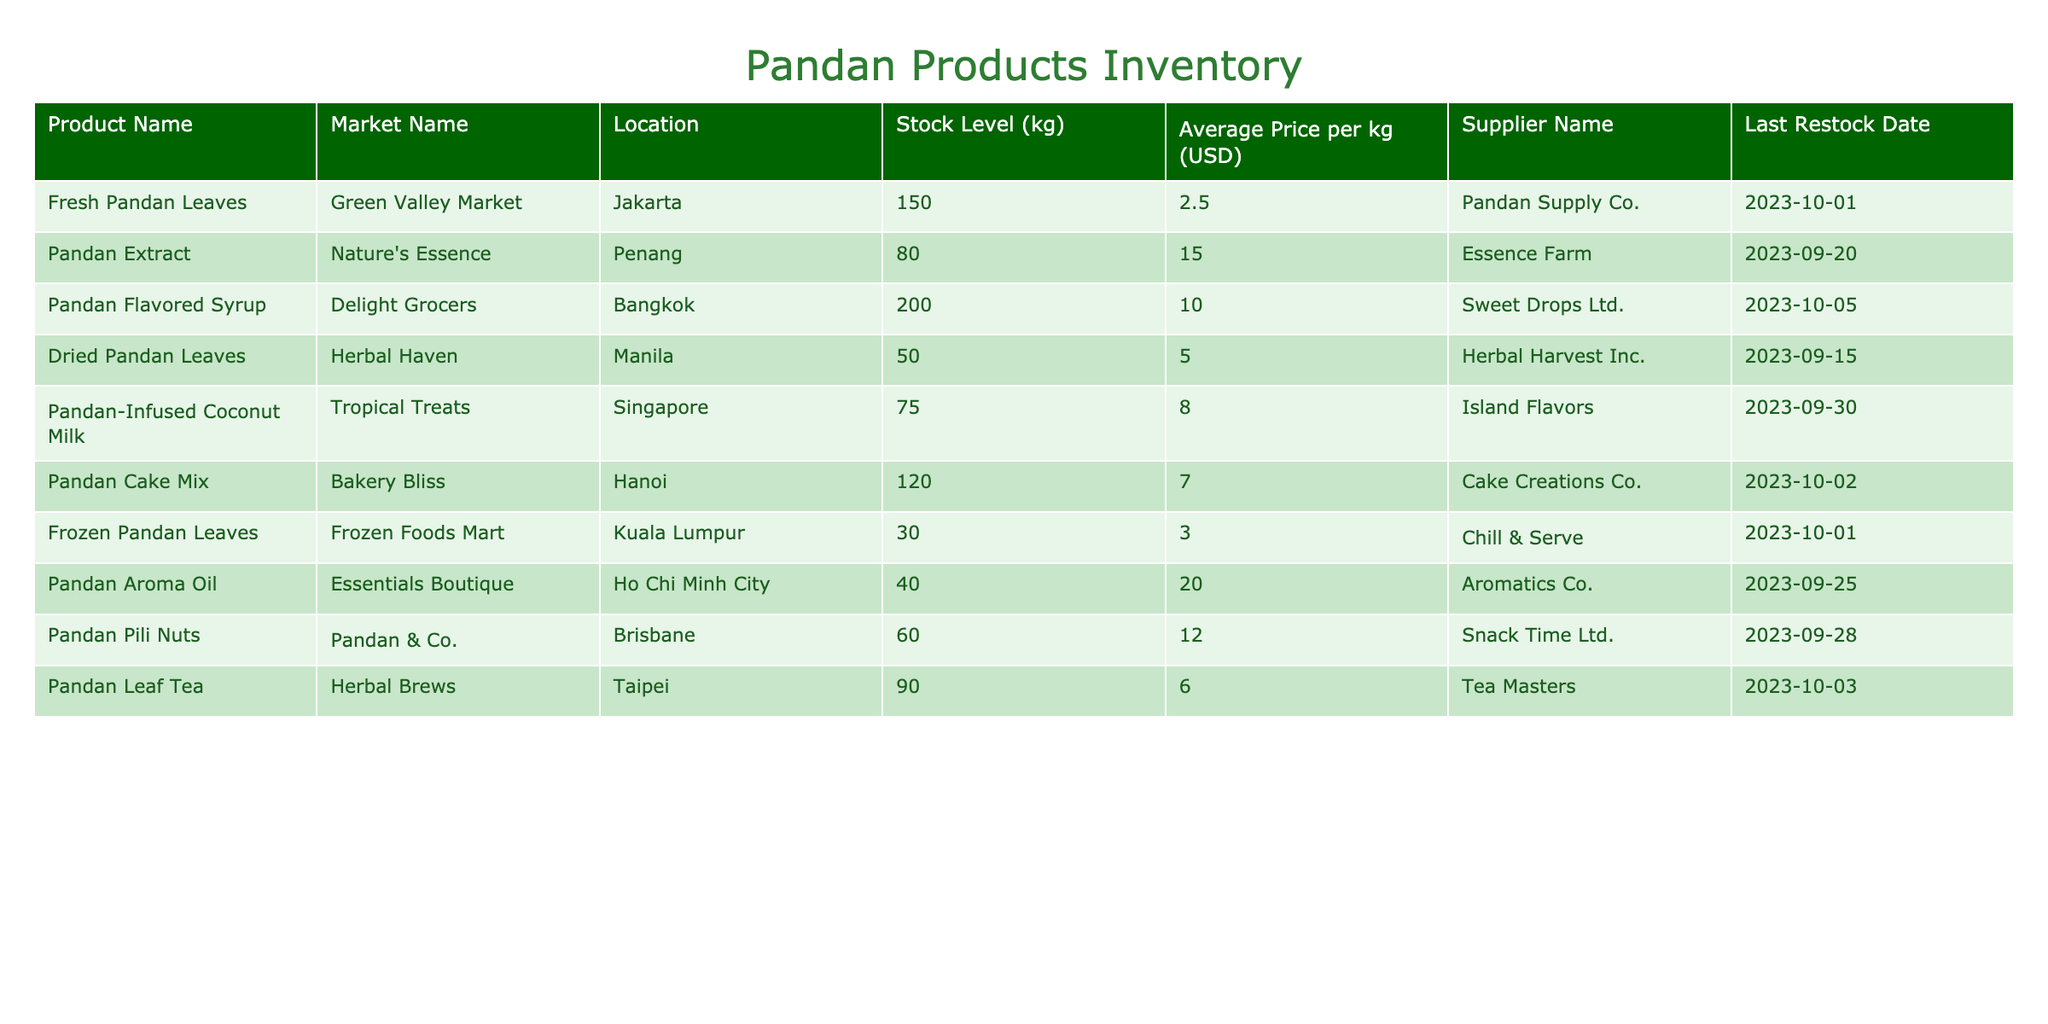What is the stock level of Fresh Pandan Leaves at Green Valley Market? The stock level of Fresh Pandan Leaves is listed under the "Stock Level (kg)" column for Green Valley Market. Looking at the table, it shows a stock level of 150 kg.
Answer: 150 kg Which product has the highest average price per kg? To find out which product has the highest price, we can compare the "Average Price per kg (USD)" values across all products. The Pandan Aroma Oil has the highest price listed at 20.00 USD.
Answer: 20.00 USD What are the stock levels of Pandan products available in Singapore? In Singapore, we have one product, which is Pandan-Infused Coconut Milk. The stock level for this product is 75 kg, as visible in the table.
Answer: 75 kg Is the stock level of Frozen Pandan Leaves greater than 50 kg? The stock level for Frozen Pandan Leaves is listed as 30 kg. Since 30 is less than 50, we can confidently answer no to this question.
Answer: No What is the total stock level of Pandan products from suppliers with names that include "Pandan"? The suppliers with names including "Pandan" are Pandan Supply Co., Pandan & Co. We need to sum their stock levels (150 kg for Fresh Pandan Leaves and 60 kg for Pandan Pili Nuts). Therefore, the total is 150 + 60 = 210 kg.
Answer: 210 kg Are there any products with a stock level less than 40 kg? Looking through the stock levels in the table, there are no products listed with a stock level below 30 kg for Frozen Pandan Leaves. Hence, the statement is true.
Answer: Yes What is the average stock level of all Pandan products? We first sum all the stock levels: 150 + 80 + 200 + 50 + 75 + 120 + 30 + 40 + 60 + 90 = 895 kg. Since there are 10 products, we divide 895 kg by 10 to get the average, which is 89.5 kg.
Answer: 89.5 kg Which product was last restocked on October 1st, 2023? We can look for the "Last Restock Date" column to find any entries matching October 1st, 2023. The products Fresh Pandan Leaves and Frozen Pandan Leaves match this date.
Answer: Fresh Pandan Leaves, Frozen Pandan Leaves What is the total average price per kg for all products from local markets? We can find the total by summing each product's average price: 2.50 + 15.00 + 10.00 + 5.00 + 8.00 + 7.00 + 3.00 + 20.00 + 12.00 + 6.00 = 88.50 USD. We then divide this by the number of products, which is 10, resulting in an average price of 8.85 USD per kg.
Answer: 8.85 USD 